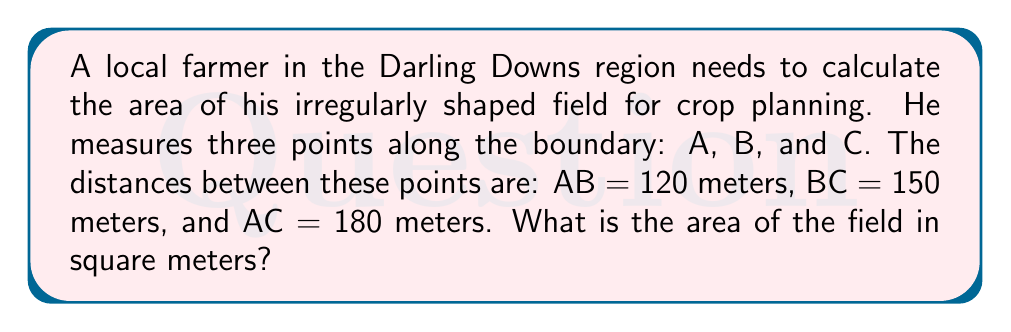Can you answer this question? Let's solve this problem step-by-step using Heron's formula:

1) First, we need to calculate the semi-perimeter (s) of the triangle:
   $s = \frac{a + b + c}{2}$, where a, b, and c are the side lengths.
   
   $s = \frac{120 + 150 + 180}{2} = \frac{450}{2} = 225$ meters

2) Now we can use Heron's formula to calculate the area:
   $A = \sqrt{s(s-a)(s-b)(s-c)}$

3) Let's substitute the values:
   $A = \sqrt{225(225-120)(225-150)(225-180)}$

4) Simplify:
   $A = \sqrt{225 \cdot 105 \cdot 75 \cdot 45}$

5) Calculate:
   $A = \sqrt{79,453,125} \approx 8,913.71$ square meters

[asy]
unitsize(0.5cm);
pair A = (0,0), B = (12,0), C = (6,8);
draw(A--B--C--A);
label("A", A, SW);
label("B", B, SE);
label("C", C, N);
label("120m", (A+B)/2, S);
label("150m", (B+C)/2, NE);
label("180m", (A+C)/2, NW);
[/asy]
Answer: 8,913.71 m² 